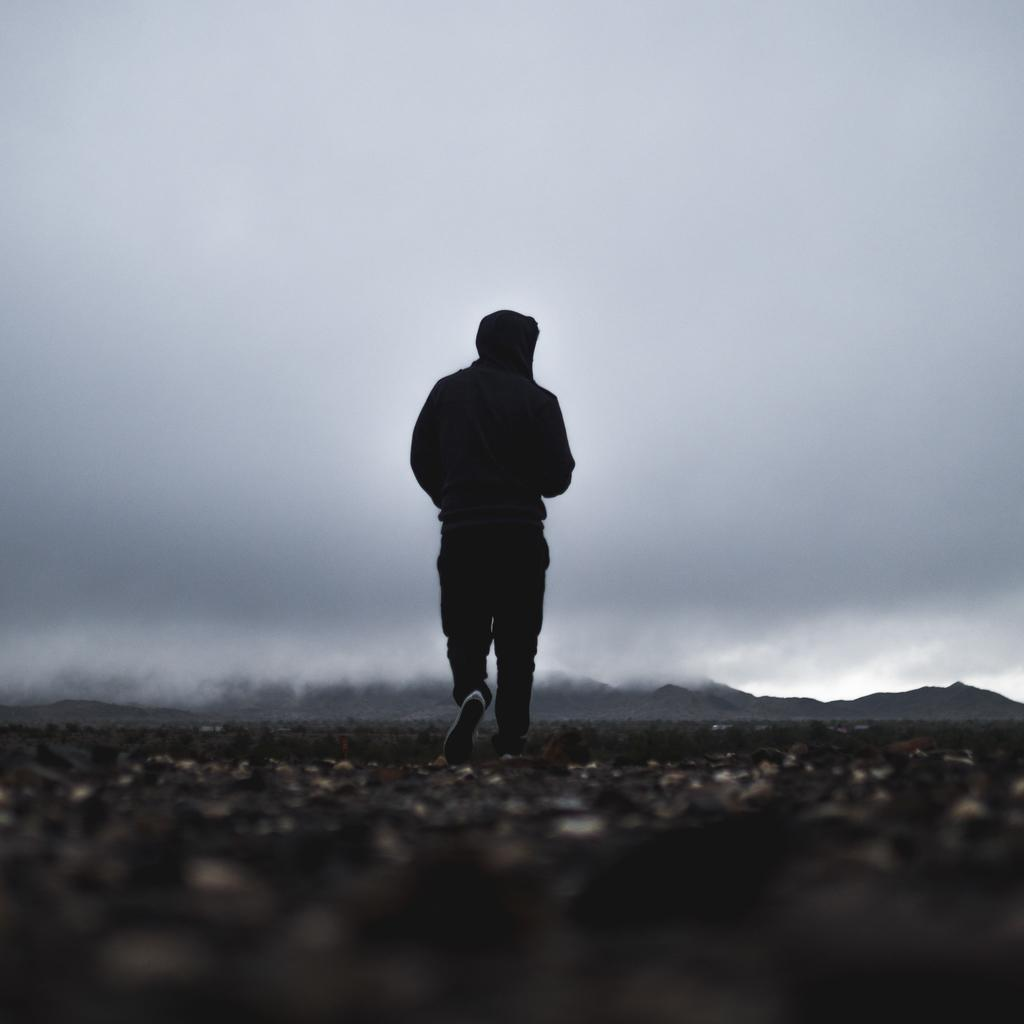What is the person in the image doing? There is a person walking in the image. What is the person wearing? The person is wearing a black color hoodie. What can be seen in the background of the image? There are hills and the sky visible in the background of the image. What is the condition of the sky in the sky? There are clouds in the sky. What type of wine is the person holding in the image? There is no wine present in the image; the person is walking and wearing a black color hoodie. 